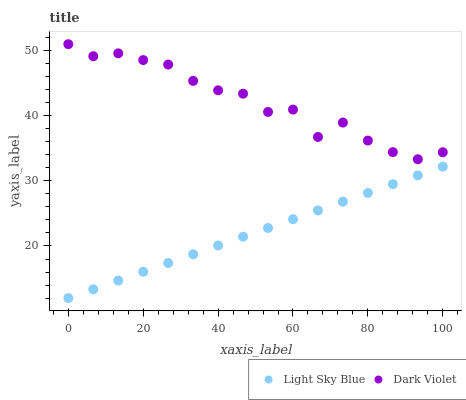Does Light Sky Blue have the minimum area under the curve?
Answer yes or no. Yes. Does Dark Violet have the maximum area under the curve?
Answer yes or no. Yes. Does Dark Violet have the minimum area under the curve?
Answer yes or no. No. Is Light Sky Blue the smoothest?
Answer yes or no. Yes. Is Dark Violet the roughest?
Answer yes or no. Yes. Is Dark Violet the smoothest?
Answer yes or no. No. Does Light Sky Blue have the lowest value?
Answer yes or no. Yes. Does Dark Violet have the lowest value?
Answer yes or no. No. Does Dark Violet have the highest value?
Answer yes or no. Yes. Is Light Sky Blue less than Dark Violet?
Answer yes or no. Yes. Is Dark Violet greater than Light Sky Blue?
Answer yes or no. Yes. Does Light Sky Blue intersect Dark Violet?
Answer yes or no. No. 